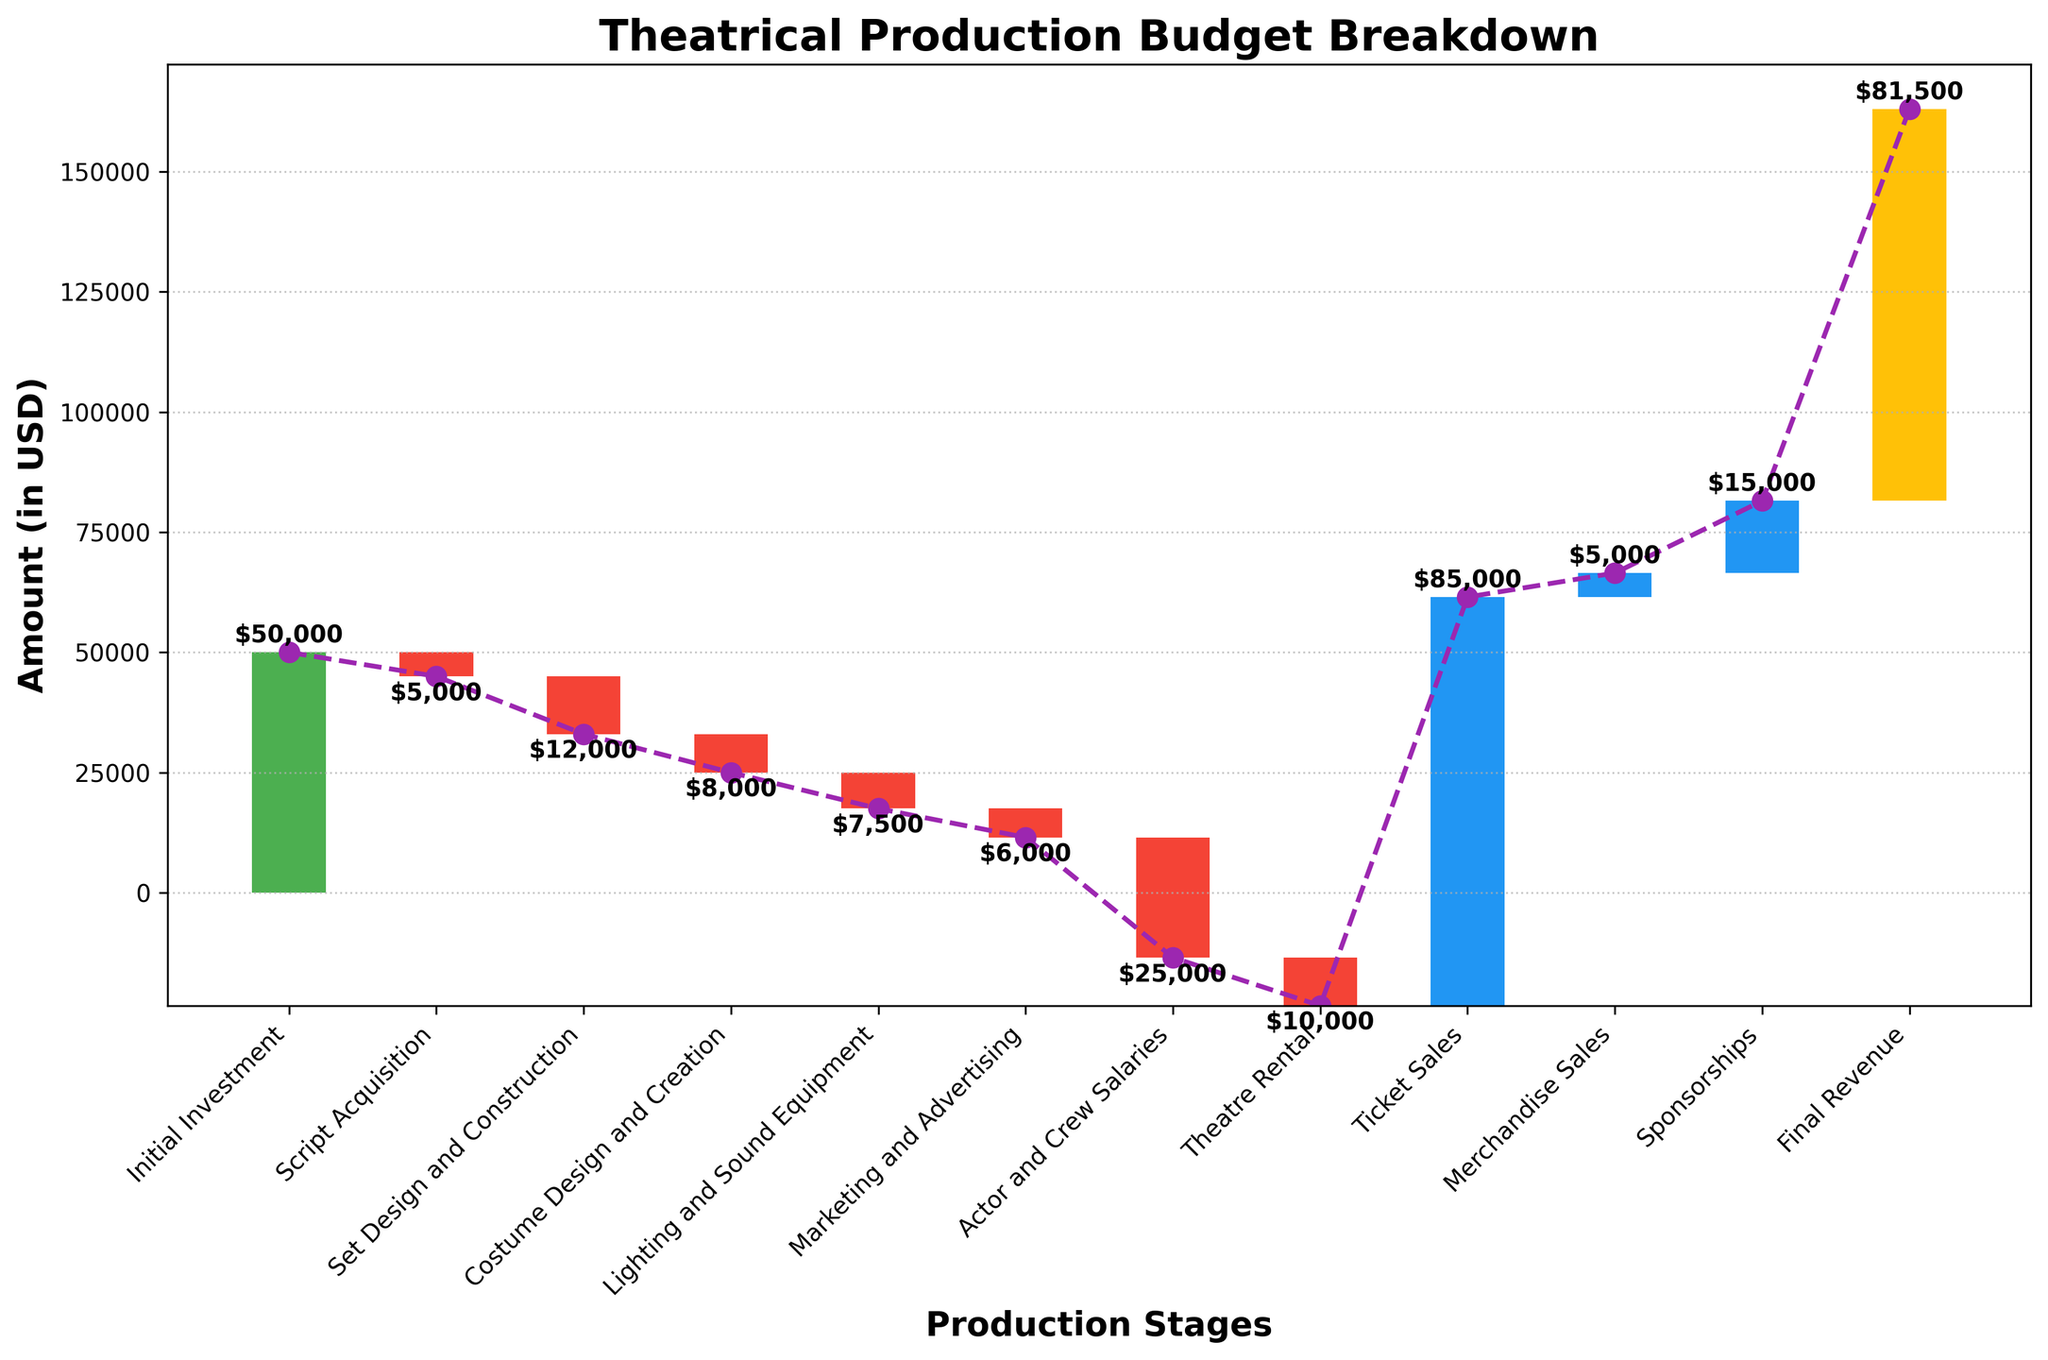What's the title of the chart? The title is located at the top of the chart. It indicates what the chart is describing or summarizing.
Answer: Theatrical Production Budget Breakdown What is the initial investment? The initial investment is usually the first category displayed, often marked in green or with a positive bar.
Answer: $50,000 How much was spent on set design and construction? The amount spent on set design and construction is the value associated with the "Set Design and Construction" category and is depicted typically with a red bar.
Answer: $12,000 What stage incurred the highest negative cost? You need to find the largest negative value among all categories and amounts. "Actor and Crew Salaries" has the most significant downward bar.
Answer: Actor and Crew Salaries What is the total revenue from ticket sales? Look for the "Ticket Sales" category, which is generally marked with a positive bar.
Answer: $85,000 Which expense category is represented by the smallest negative value? Compare the absolute values of all negative expense categories. "Script Acquisition" has the smallest spent amount.
Answer: Script Acquisition Sum of all expenses from script acquisition to theatre rental? Add together all the negative amounts from "Script Acquisition" to "Theatre Rental": -$5,000 + -$12,000 + -$8,000 + -$7,500 + -$6,000 + -$25,000 + -$10,000 = -$73,500.
Answer: -$73,500 What’s the total amount of positive contributions (ticket sales, merchandise sales, sponsorships)? Add together the positive amounts: $85,000 + $5,000 + $15,000 = $105,000.
Answer: $105,000 What's the difference between the initial investment and the final revenue? Subtract the initial investment from the final revenue: $81,500 - $50,000 = $31,500.
Answer: $31,500 How does revenue from sponsorships compare to revenue from merchandise sales? Compare the values for sponsorships and merchandise sales. Sponsorships contribute more as $15,000 compared to $5,000 from merchandise.
Answer: Sponsorships contribute more 